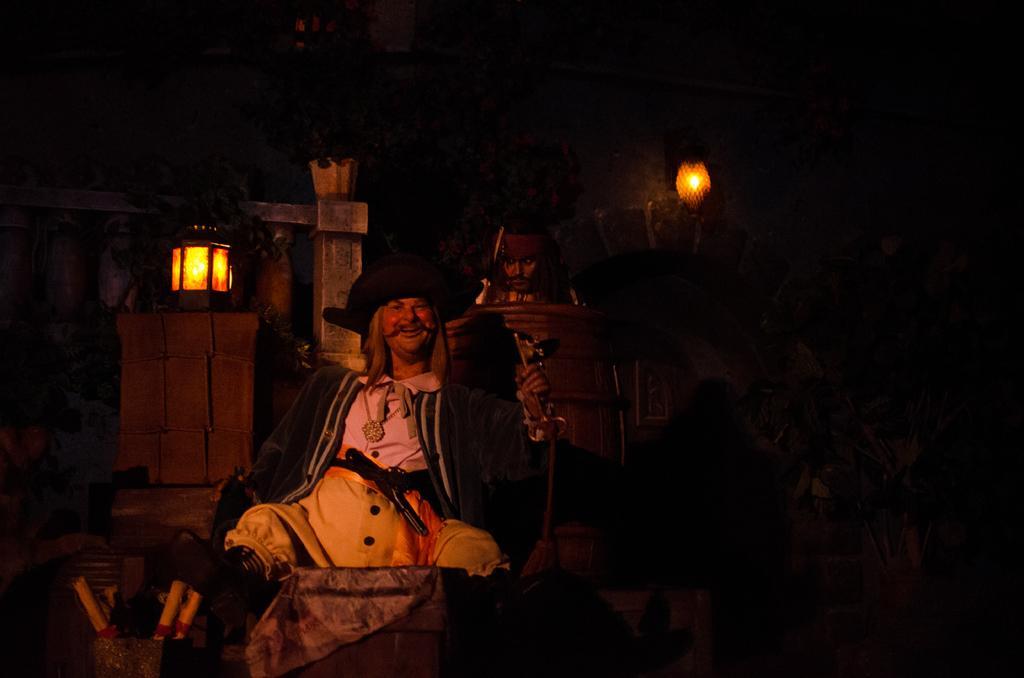Can you describe this image briefly? A person is sitting wearing a pirate costume. A person is standing inside a barrel. There are lamps at the back. 